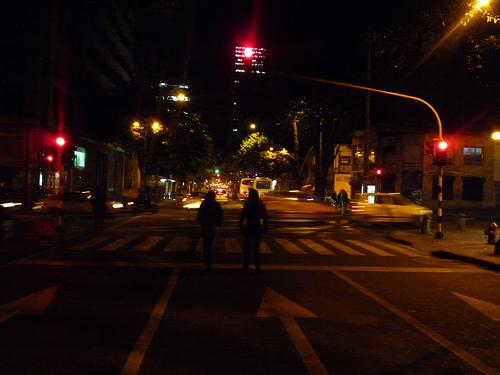Question: where is this scene?
Choices:
A. On the road.
B. At the farm.
C. City street.
D. In the park.
Answer with the letter. Answer: C Question: what are the people doing?
Choices:
A. Running.
B. Walking.
C. Riding bikes.
D. Commuting.
Answer with the letter. Answer: B Question: when is this scene?
Choices:
A. Daytime.
B. Morning.
C. Afternoon.
D. Nighttime.
Answer with the letter. Answer: D Question: what are the lights in front?
Choices:
A. The house.
B. The school.
C. Traffic lights.
D. The bus.
Answer with the letter. Answer: C Question: how dark is it?
Choices:
A. Very dark.
B. Black.
C. Dim.
D. Gloomy.
Answer with the letter. Answer: A Question: why is it brightly lit?
Choices:
A. The lights are on.
B. It is daylight.
C. Many lights.
D. It is highbeams.
Answer with the letter. Answer: C 